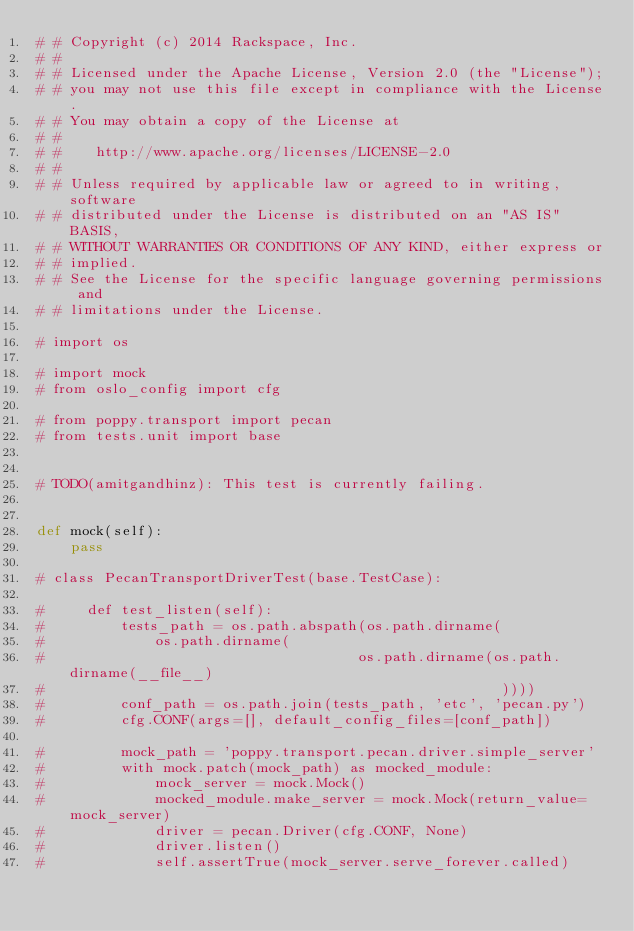<code> <loc_0><loc_0><loc_500><loc_500><_Python_># # Copyright (c) 2014 Rackspace, Inc.
# #
# # Licensed under the Apache License, Version 2.0 (the "License");
# # you may not use this file except in compliance with the License.
# # You may obtain a copy of the License at
# #
# #    http://www.apache.org/licenses/LICENSE-2.0
# #
# # Unless required by applicable law or agreed to in writing, software
# # distributed under the License is distributed on an "AS IS" BASIS,
# # WITHOUT WARRANTIES OR CONDITIONS OF ANY KIND, either express or
# # implied.
# # See the License for the specific language governing permissions and
# # limitations under the License.

# import os

# import mock
# from oslo_config import cfg

# from poppy.transport import pecan
# from tests.unit import base


# TODO(amitgandhinz): This test is currently failing.


def mock(self):
    pass

# class PecanTransportDriverTest(base.TestCase):

#     def test_listen(self):
#         tests_path = os.path.abspath(os.path.dirname(
#             os.path.dirname(
#                                     os.path.dirname(os.path.dirname(__file__)
#                                                      ))))
#         conf_path = os.path.join(tests_path, 'etc', 'pecan.py')
#         cfg.CONF(args=[], default_config_files=[conf_path])

#         mock_path = 'poppy.transport.pecan.driver.simple_server'
#         with mock.patch(mock_path) as mocked_module:
#             mock_server = mock.Mock()
#             mocked_module.make_server = mock.Mock(return_value=mock_server)
#             driver = pecan.Driver(cfg.CONF, None)
#             driver.listen()
#             self.assertTrue(mock_server.serve_forever.called)
</code> 